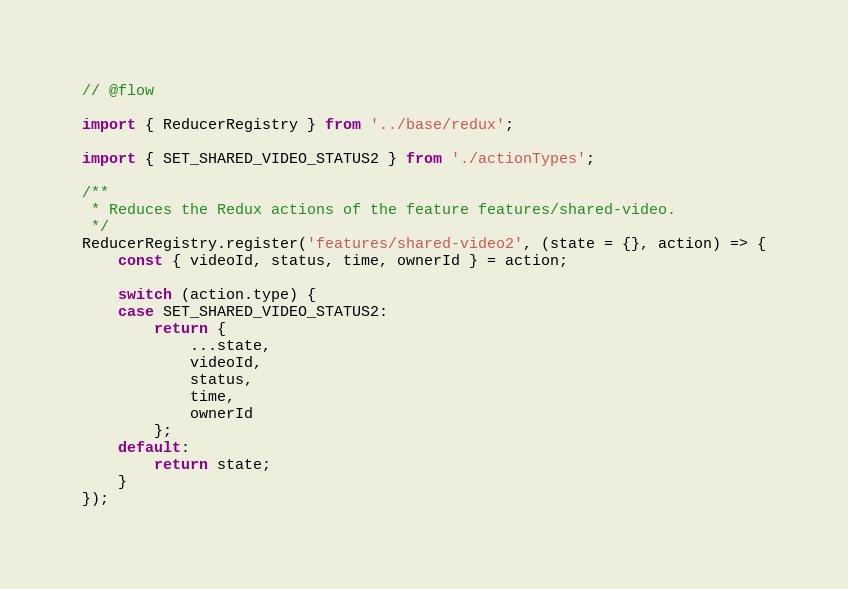<code> <loc_0><loc_0><loc_500><loc_500><_JavaScript_>// @flow

import { ReducerRegistry } from '../base/redux';

import { SET_SHARED_VIDEO_STATUS2 } from './actionTypes';

/**
 * Reduces the Redux actions of the feature features/shared-video.
 */
ReducerRegistry.register('features/shared-video2', (state = {}, action) => {
    const { videoId, status, time, ownerId } = action;

    switch (action.type) {
    case SET_SHARED_VIDEO_STATUS2:
        return {
            ...state,
            videoId,
            status,
            time,
            ownerId
        };
    default:
        return state;
    }
});
</code> 